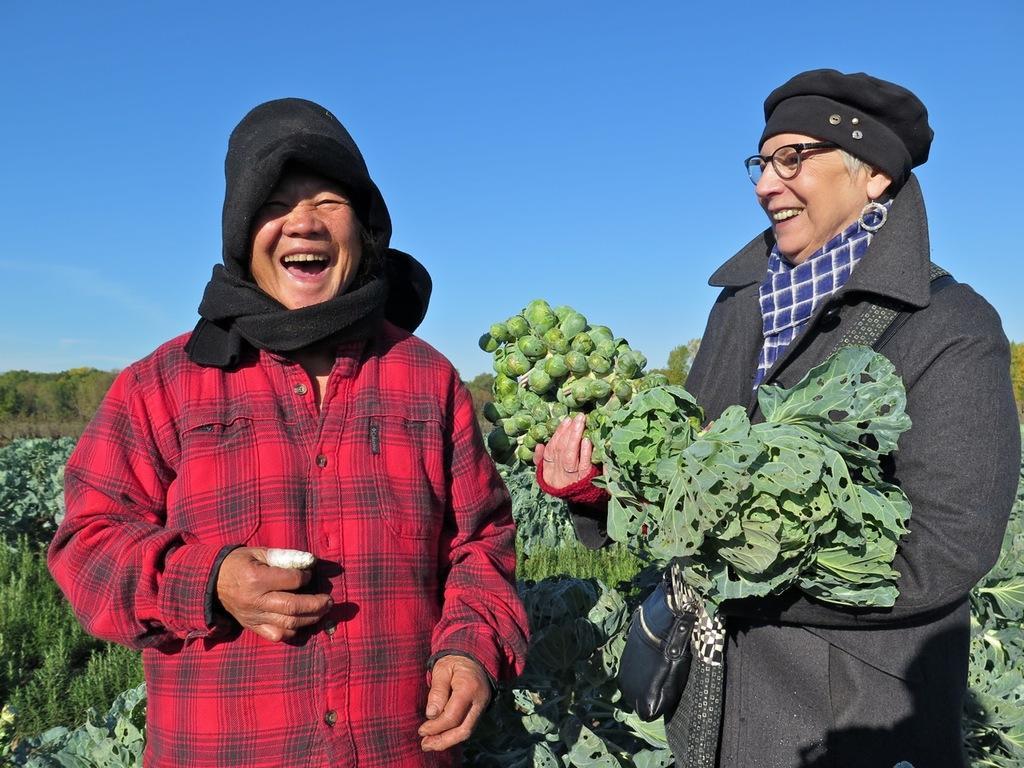Describe this image in one or two sentences. In this image, there are a few people. Among them, we can see a person wearing spectacles is holding some objects. We can also see some plants and trees. We can also see the sky. 